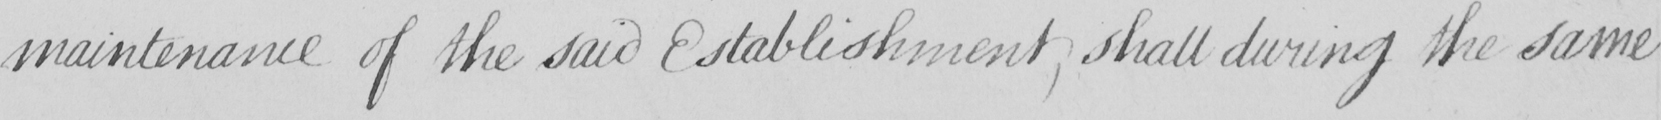Can you tell me what this handwritten text says? maintenance of the said Establishment , shall during the same 